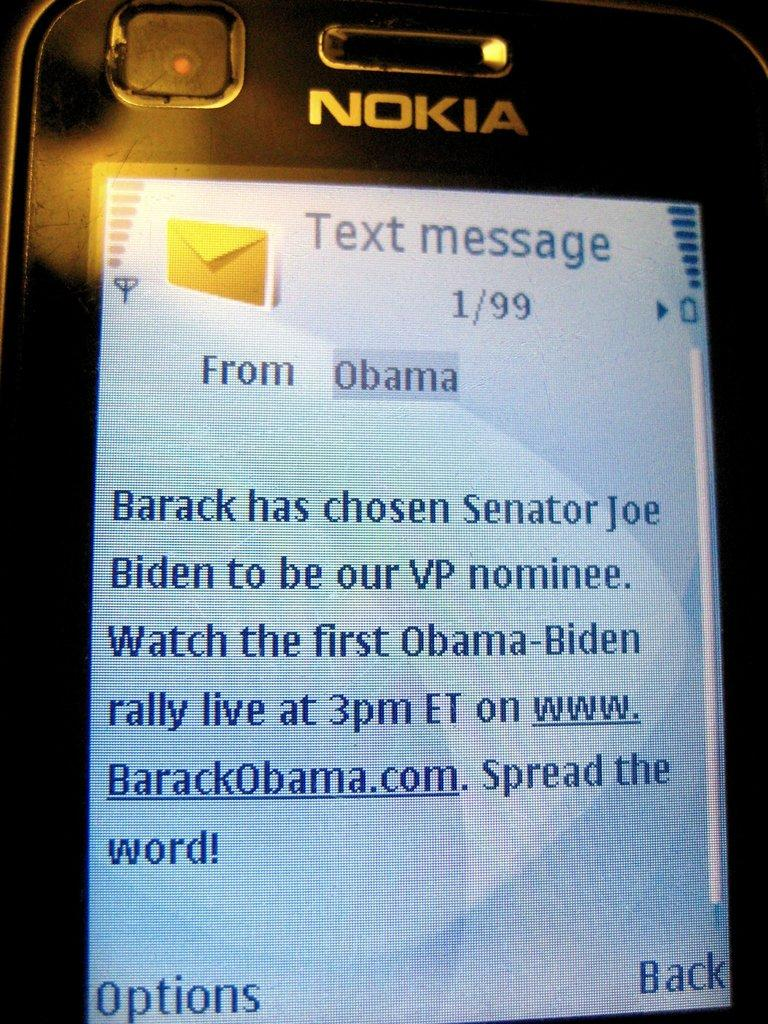Provide a one-sentence caption for the provided image. Nokia phone showing a long message from Barack Obama. 